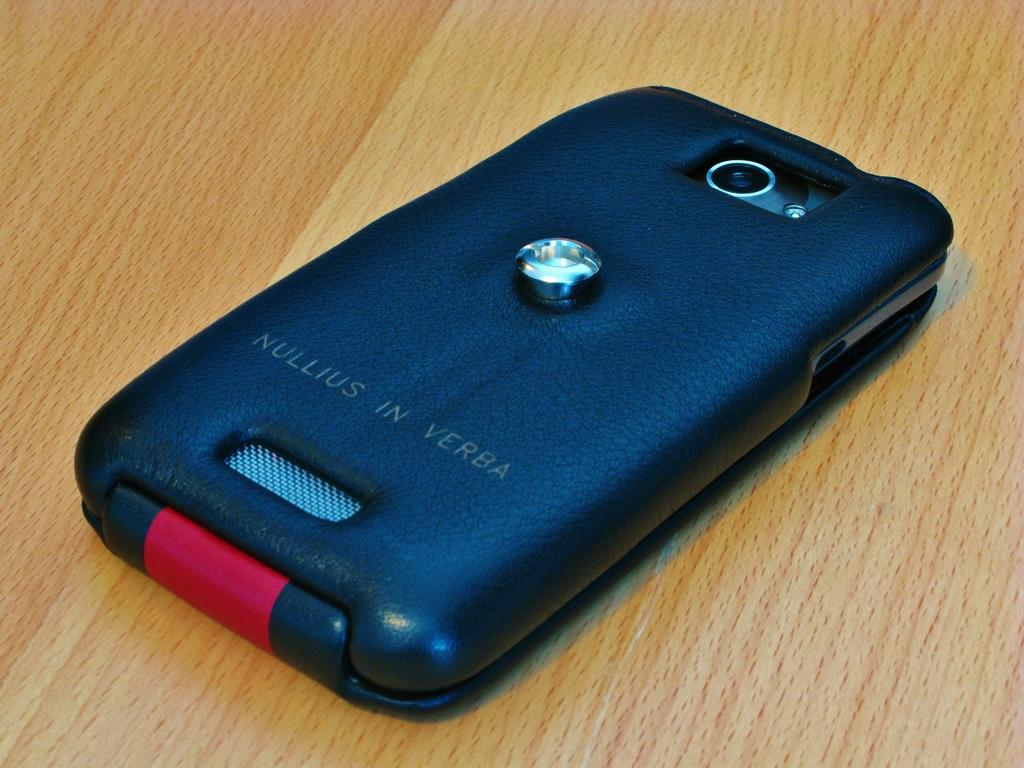<image>
Present a compact description of the photo's key features. Nullius in Verba is written at the bottom of a blue backed cell phone. 